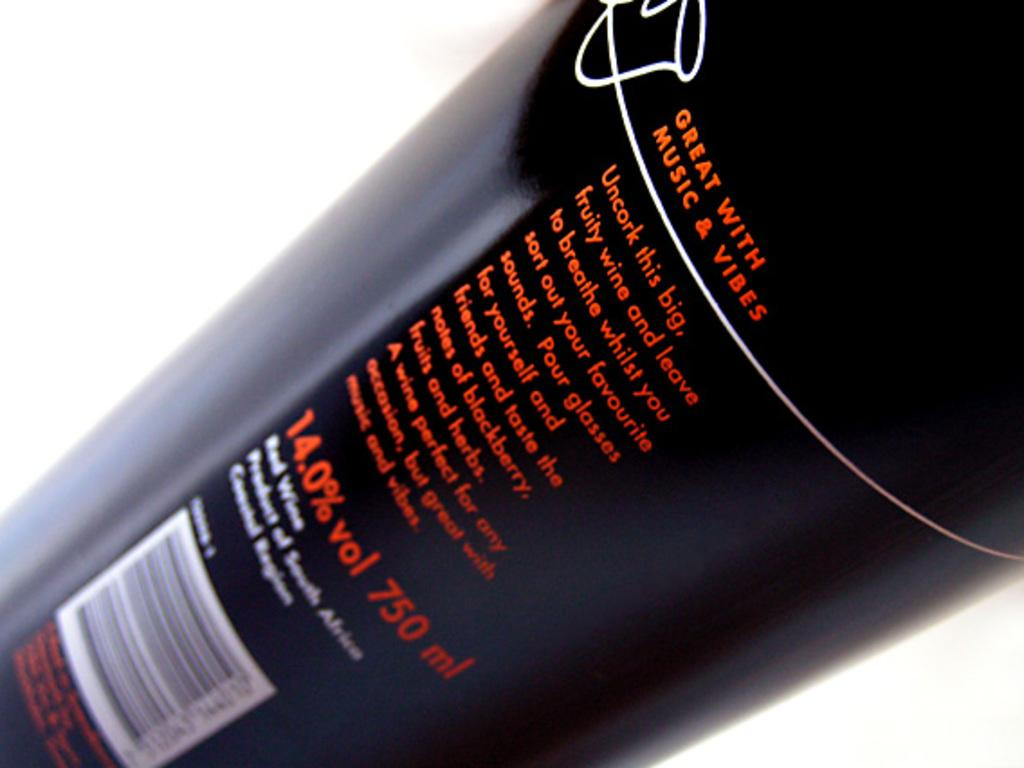Provide a one-sentence caption for the provided image. The back of a wine bottle that is great with music &vibes. 